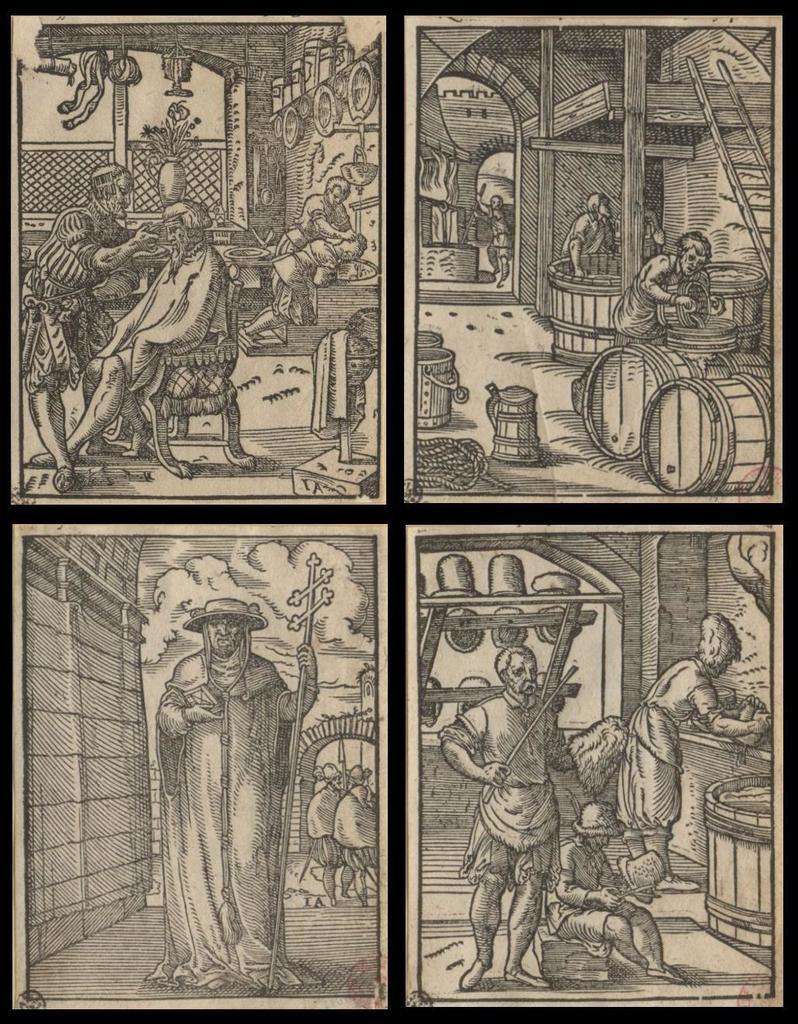How would you summarize this image in a sentence or two? This is a black and white image. In this image we can see collage pictures of drawings of a person's. 